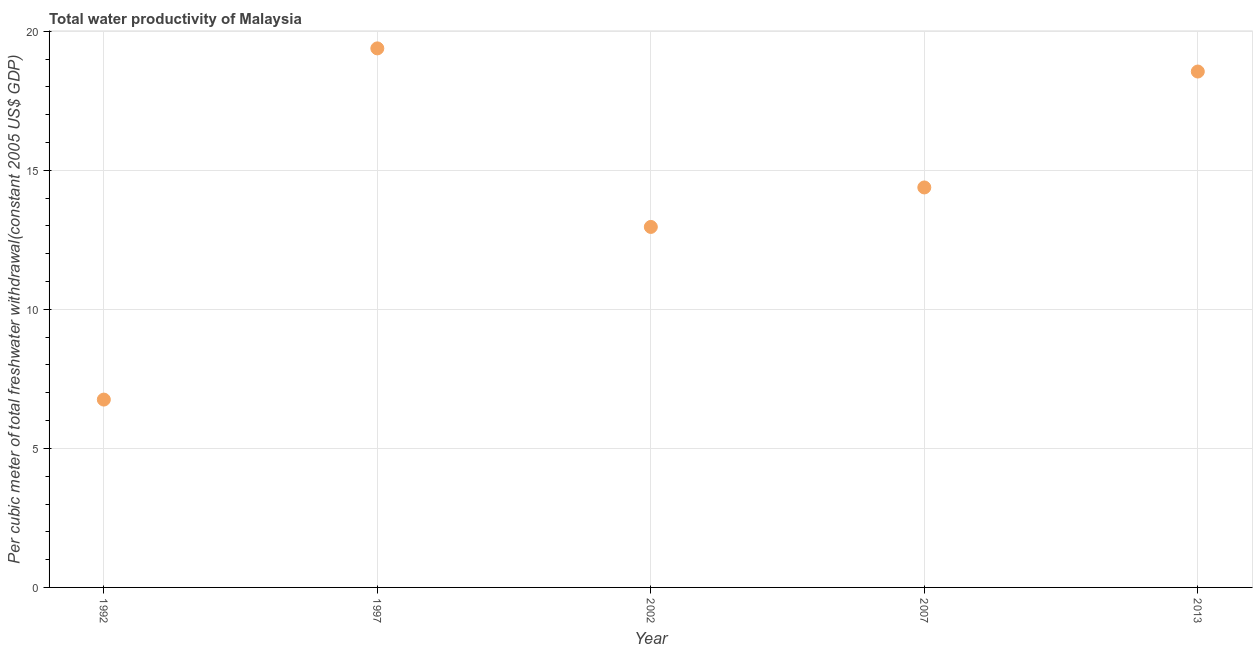What is the total water productivity in 2002?
Your answer should be compact. 12.96. Across all years, what is the maximum total water productivity?
Keep it short and to the point. 19.38. Across all years, what is the minimum total water productivity?
Offer a terse response. 6.76. In which year was the total water productivity minimum?
Give a very brief answer. 1992. What is the sum of the total water productivity?
Offer a very short reply. 72.04. What is the difference between the total water productivity in 1997 and 2013?
Provide a succinct answer. 0.83. What is the average total water productivity per year?
Offer a very short reply. 14.41. What is the median total water productivity?
Give a very brief answer. 14.38. In how many years, is the total water productivity greater than 14 US$?
Offer a terse response. 3. What is the ratio of the total water productivity in 1997 to that in 2007?
Keep it short and to the point. 1.35. Is the difference between the total water productivity in 1997 and 2002 greater than the difference between any two years?
Provide a short and direct response. No. What is the difference between the highest and the second highest total water productivity?
Offer a terse response. 0.83. What is the difference between the highest and the lowest total water productivity?
Keep it short and to the point. 12.63. In how many years, is the total water productivity greater than the average total water productivity taken over all years?
Offer a terse response. 2. How many dotlines are there?
Offer a very short reply. 1. How many years are there in the graph?
Make the answer very short. 5. Are the values on the major ticks of Y-axis written in scientific E-notation?
Keep it short and to the point. No. Does the graph contain any zero values?
Give a very brief answer. No. Does the graph contain grids?
Make the answer very short. Yes. What is the title of the graph?
Provide a short and direct response. Total water productivity of Malaysia. What is the label or title of the X-axis?
Provide a succinct answer. Year. What is the label or title of the Y-axis?
Your answer should be compact. Per cubic meter of total freshwater withdrawal(constant 2005 US$ GDP). What is the Per cubic meter of total freshwater withdrawal(constant 2005 US$ GDP) in 1992?
Provide a short and direct response. 6.76. What is the Per cubic meter of total freshwater withdrawal(constant 2005 US$ GDP) in 1997?
Your response must be concise. 19.38. What is the Per cubic meter of total freshwater withdrawal(constant 2005 US$ GDP) in 2002?
Provide a short and direct response. 12.96. What is the Per cubic meter of total freshwater withdrawal(constant 2005 US$ GDP) in 2007?
Keep it short and to the point. 14.38. What is the Per cubic meter of total freshwater withdrawal(constant 2005 US$ GDP) in 2013?
Provide a succinct answer. 18.55. What is the difference between the Per cubic meter of total freshwater withdrawal(constant 2005 US$ GDP) in 1992 and 1997?
Give a very brief answer. -12.63. What is the difference between the Per cubic meter of total freshwater withdrawal(constant 2005 US$ GDP) in 1992 and 2002?
Your answer should be compact. -6.21. What is the difference between the Per cubic meter of total freshwater withdrawal(constant 2005 US$ GDP) in 1992 and 2007?
Your response must be concise. -7.63. What is the difference between the Per cubic meter of total freshwater withdrawal(constant 2005 US$ GDP) in 1992 and 2013?
Keep it short and to the point. -11.8. What is the difference between the Per cubic meter of total freshwater withdrawal(constant 2005 US$ GDP) in 1997 and 2002?
Make the answer very short. 6.42. What is the difference between the Per cubic meter of total freshwater withdrawal(constant 2005 US$ GDP) in 1997 and 2007?
Your answer should be very brief. 5. What is the difference between the Per cubic meter of total freshwater withdrawal(constant 2005 US$ GDP) in 1997 and 2013?
Offer a very short reply. 0.83. What is the difference between the Per cubic meter of total freshwater withdrawal(constant 2005 US$ GDP) in 2002 and 2007?
Keep it short and to the point. -1.42. What is the difference between the Per cubic meter of total freshwater withdrawal(constant 2005 US$ GDP) in 2002 and 2013?
Your answer should be very brief. -5.59. What is the difference between the Per cubic meter of total freshwater withdrawal(constant 2005 US$ GDP) in 2007 and 2013?
Ensure brevity in your answer.  -4.17. What is the ratio of the Per cubic meter of total freshwater withdrawal(constant 2005 US$ GDP) in 1992 to that in 1997?
Offer a terse response. 0.35. What is the ratio of the Per cubic meter of total freshwater withdrawal(constant 2005 US$ GDP) in 1992 to that in 2002?
Make the answer very short. 0.52. What is the ratio of the Per cubic meter of total freshwater withdrawal(constant 2005 US$ GDP) in 1992 to that in 2007?
Your answer should be compact. 0.47. What is the ratio of the Per cubic meter of total freshwater withdrawal(constant 2005 US$ GDP) in 1992 to that in 2013?
Your response must be concise. 0.36. What is the ratio of the Per cubic meter of total freshwater withdrawal(constant 2005 US$ GDP) in 1997 to that in 2002?
Keep it short and to the point. 1.5. What is the ratio of the Per cubic meter of total freshwater withdrawal(constant 2005 US$ GDP) in 1997 to that in 2007?
Give a very brief answer. 1.35. What is the ratio of the Per cubic meter of total freshwater withdrawal(constant 2005 US$ GDP) in 1997 to that in 2013?
Your answer should be compact. 1.04. What is the ratio of the Per cubic meter of total freshwater withdrawal(constant 2005 US$ GDP) in 2002 to that in 2007?
Provide a succinct answer. 0.9. What is the ratio of the Per cubic meter of total freshwater withdrawal(constant 2005 US$ GDP) in 2002 to that in 2013?
Give a very brief answer. 0.7. What is the ratio of the Per cubic meter of total freshwater withdrawal(constant 2005 US$ GDP) in 2007 to that in 2013?
Give a very brief answer. 0.78. 